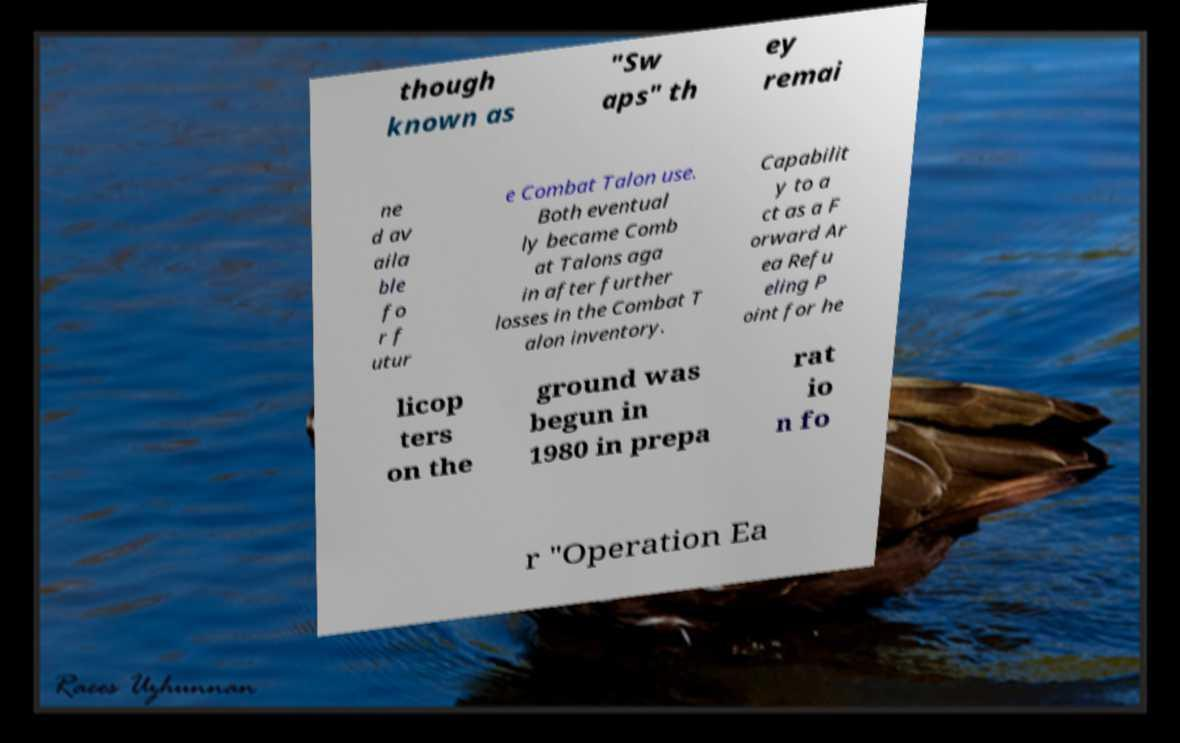For documentation purposes, I need the text within this image transcribed. Could you provide that? though known as "Sw aps" th ey remai ne d av aila ble fo r f utur e Combat Talon use. Both eventual ly became Comb at Talons aga in after further losses in the Combat T alon inventory. Capabilit y to a ct as a F orward Ar ea Refu eling P oint for he licop ters on the ground was begun in 1980 in prepa rat io n fo r "Operation Ea 